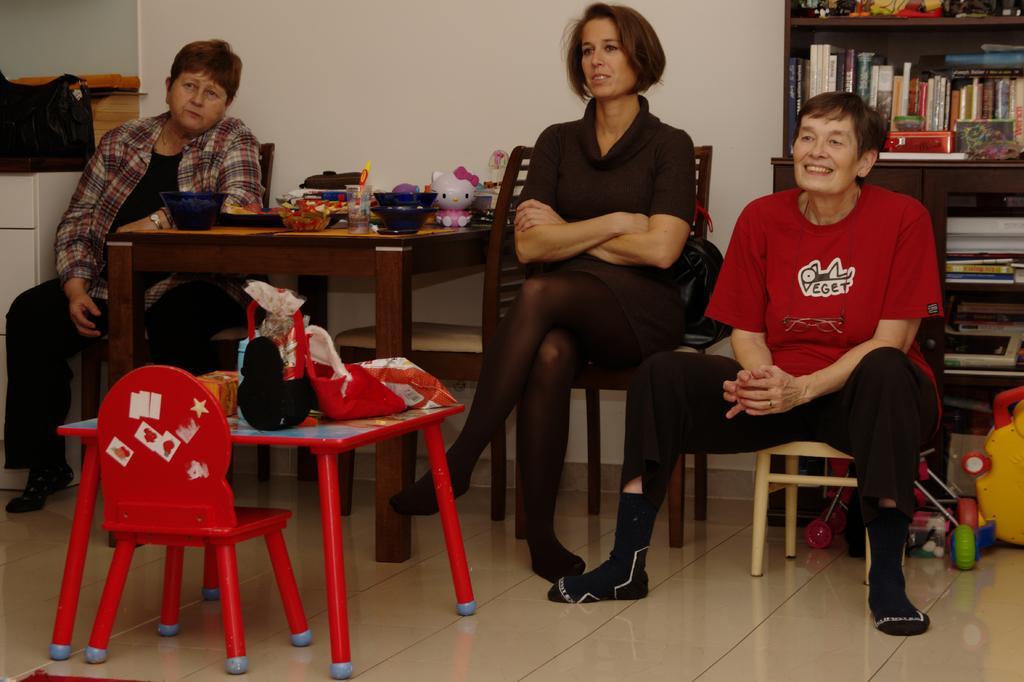In one or two sentences, can you explain what this image depicts? Bottom right side of the image people are sitting on a chairs and smiling. Top left side of the image a woman is sitting on a chair. In the middle of the image there is a table on the table there are some toys and there are some products. Top right side of the image there is a bookshelf. Behind them there is a wall. Bottom left side of the image there is a table and chair. 